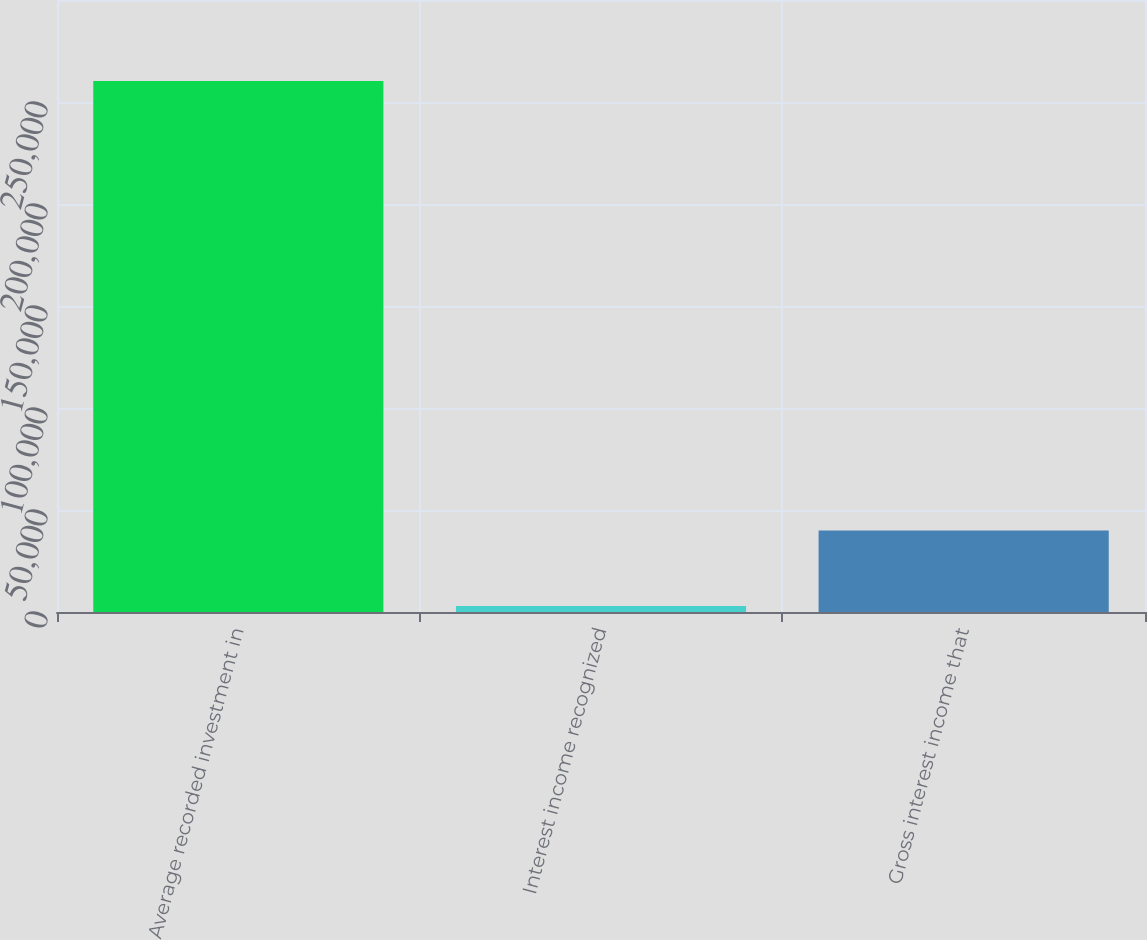<chart> <loc_0><loc_0><loc_500><loc_500><bar_chart><fcel>Average recorded investment in<fcel>Interest income recognized<fcel>Gross interest income that<nl><fcel>260251<fcel>2946<fcel>39917<nl></chart> 